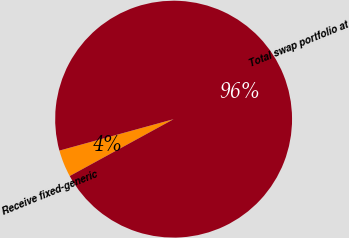Convert chart. <chart><loc_0><loc_0><loc_500><loc_500><pie_chart><fcel>Receive fixed-generic<fcel>Total swap portfolio at<nl><fcel>3.7%<fcel>96.3%<nl></chart> 